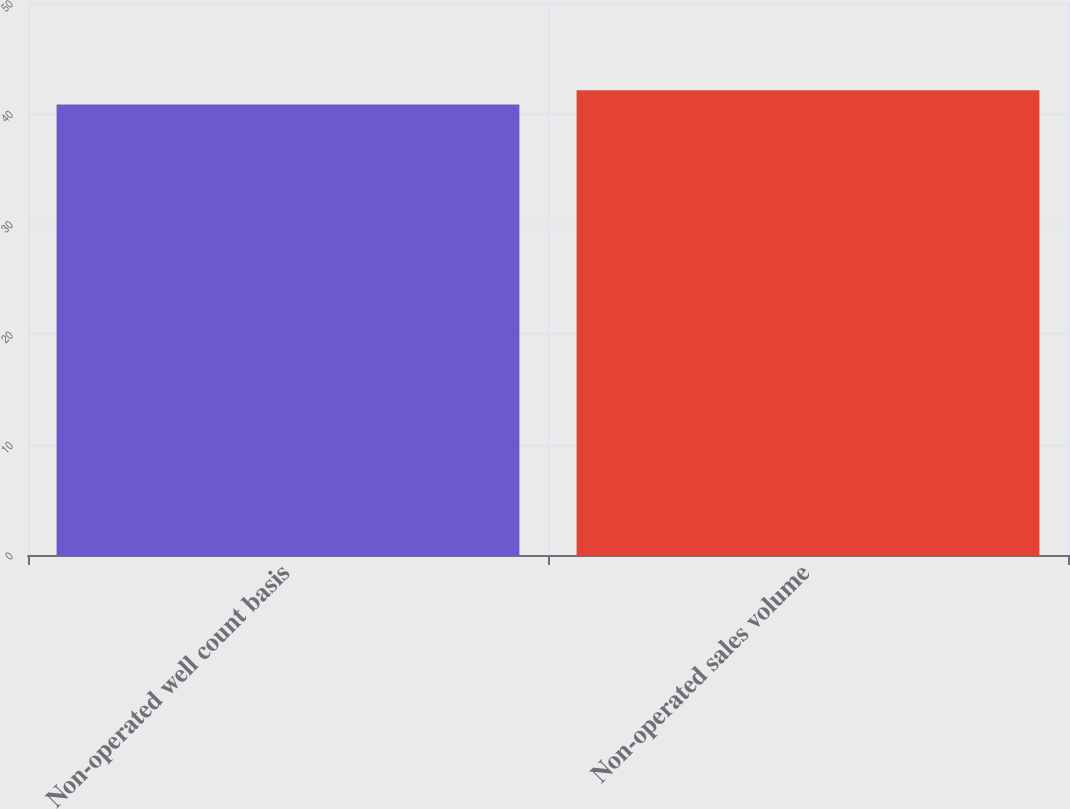<chart> <loc_0><loc_0><loc_500><loc_500><bar_chart><fcel>Non-operated well count basis<fcel>Non-operated sales volume<nl><fcel>40.8<fcel>42.1<nl></chart> 